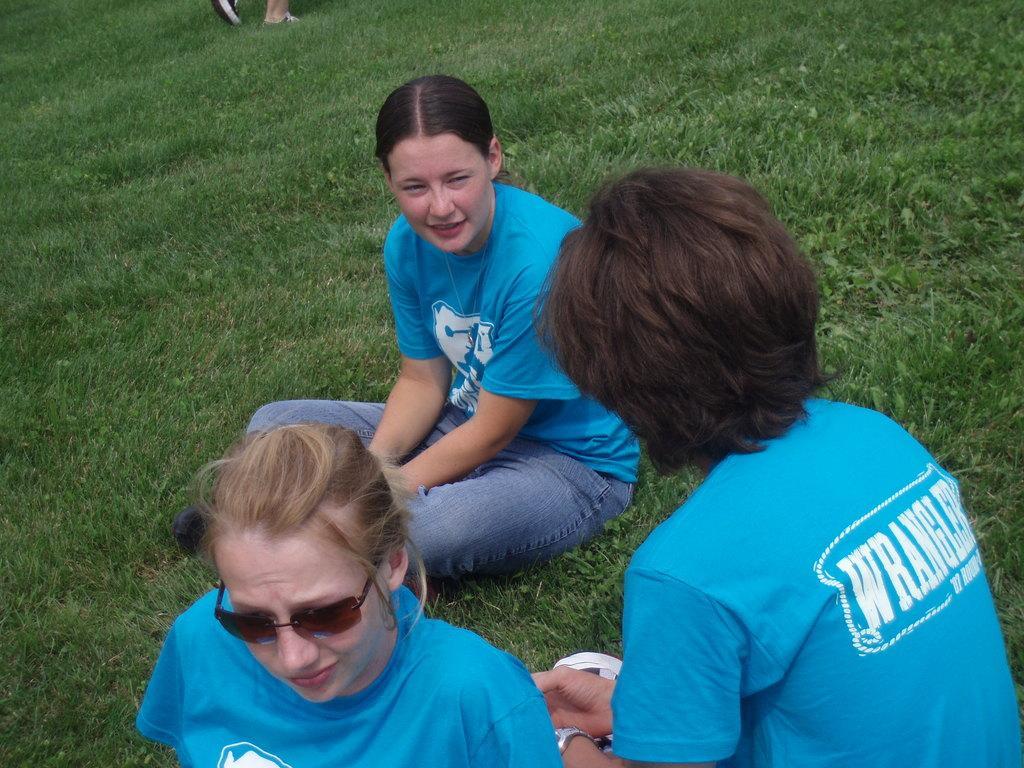Describe this image in one or two sentences. The picture consists of people and grass. On the top we can see the legs of a person. 